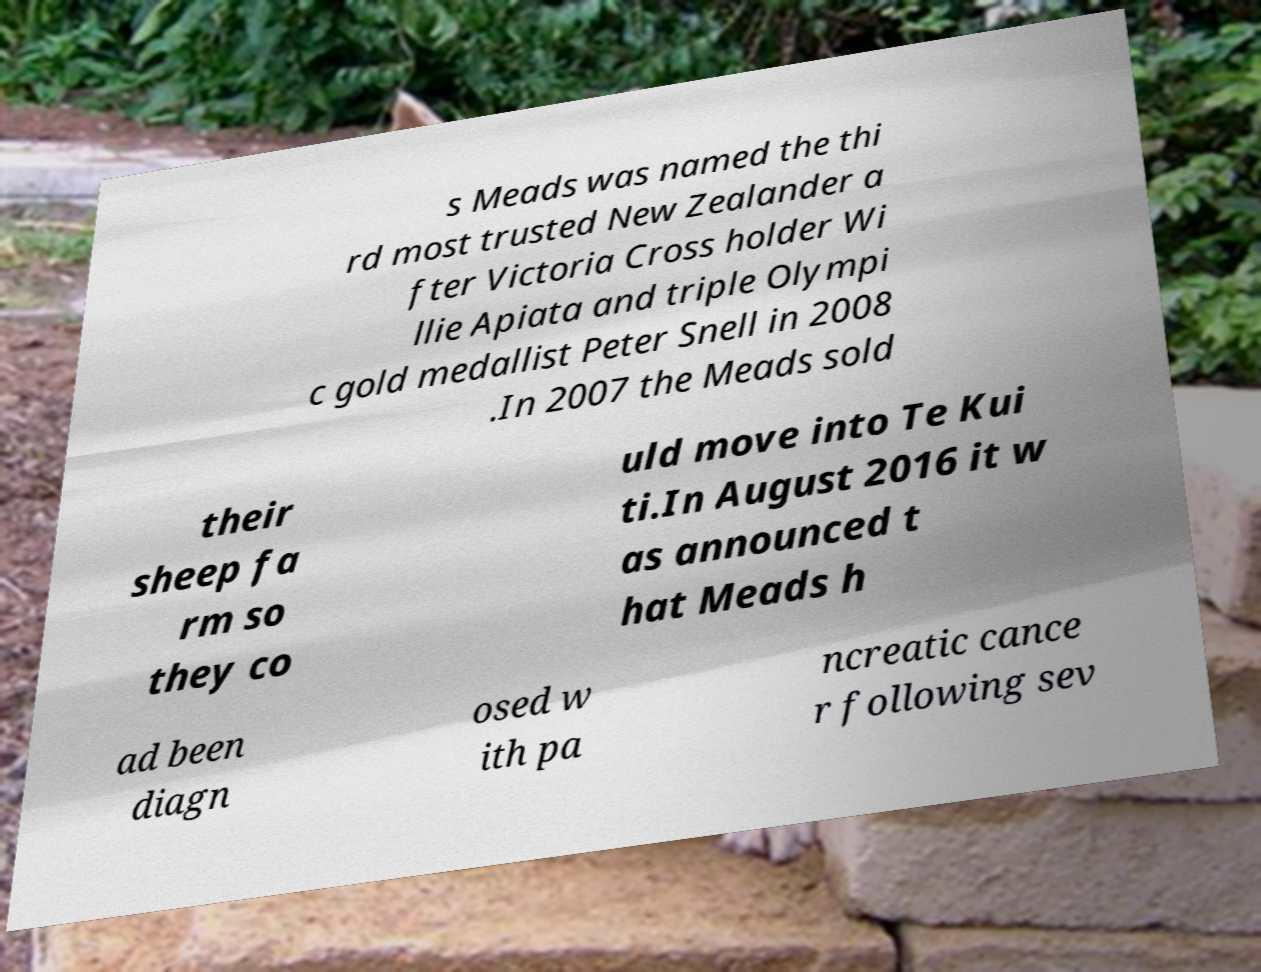Please identify and transcribe the text found in this image. s Meads was named the thi rd most trusted New Zealander a fter Victoria Cross holder Wi llie Apiata and triple Olympi c gold medallist Peter Snell in 2008 .In 2007 the Meads sold their sheep fa rm so they co uld move into Te Kui ti.In August 2016 it w as announced t hat Meads h ad been diagn osed w ith pa ncreatic cance r following sev 